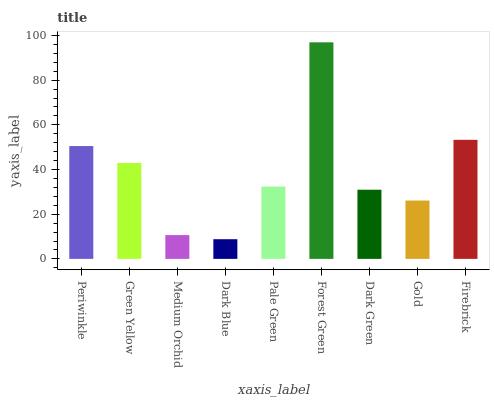Is Dark Blue the minimum?
Answer yes or no. Yes. Is Forest Green the maximum?
Answer yes or no. Yes. Is Green Yellow the minimum?
Answer yes or no. No. Is Green Yellow the maximum?
Answer yes or no. No. Is Periwinkle greater than Green Yellow?
Answer yes or no. Yes. Is Green Yellow less than Periwinkle?
Answer yes or no. Yes. Is Green Yellow greater than Periwinkle?
Answer yes or no. No. Is Periwinkle less than Green Yellow?
Answer yes or no. No. Is Pale Green the high median?
Answer yes or no. Yes. Is Pale Green the low median?
Answer yes or no. Yes. Is Green Yellow the high median?
Answer yes or no. No. Is Dark Green the low median?
Answer yes or no. No. 